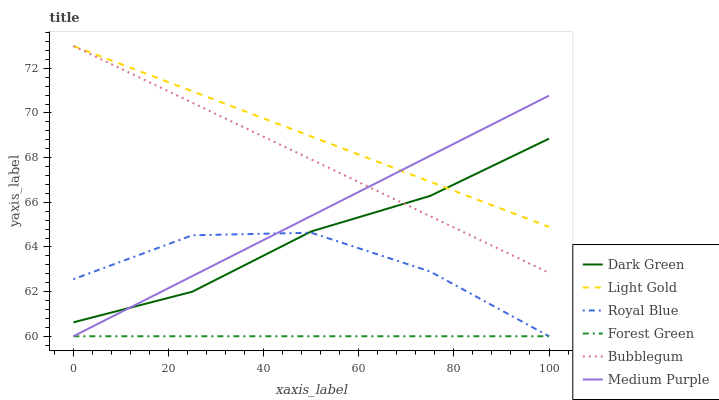Does Medium Purple have the minimum area under the curve?
Answer yes or no. No. Does Medium Purple have the maximum area under the curve?
Answer yes or no. No. Is Royal Blue the smoothest?
Answer yes or no. No. Is Medium Purple the roughest?
Answer yes or no. No. Does Light Gold have the lowest value?
Answer yes or no. No. Does Medium Purple have the highest value?
Answer yes or no. No. Is Royal Blue less than Light Gold?
Answer yes or no. Yes. Is Light Gold greater than Royal Blue?
Answer yes or no. Yes. Does Royal Blue intersect Light Gold?
Answer yes or no. No. 